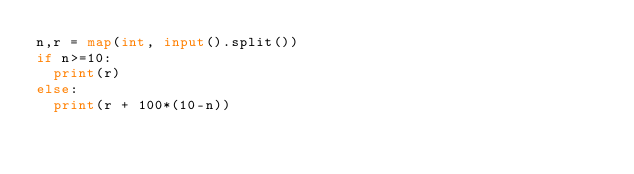<code> <loc_0><loc_0><loc_500><loc_500><_Python_>n,r = map(int, input().split())
if n>=10:
  print(r)
else:
  print(r + 100*(10-n))</code> 